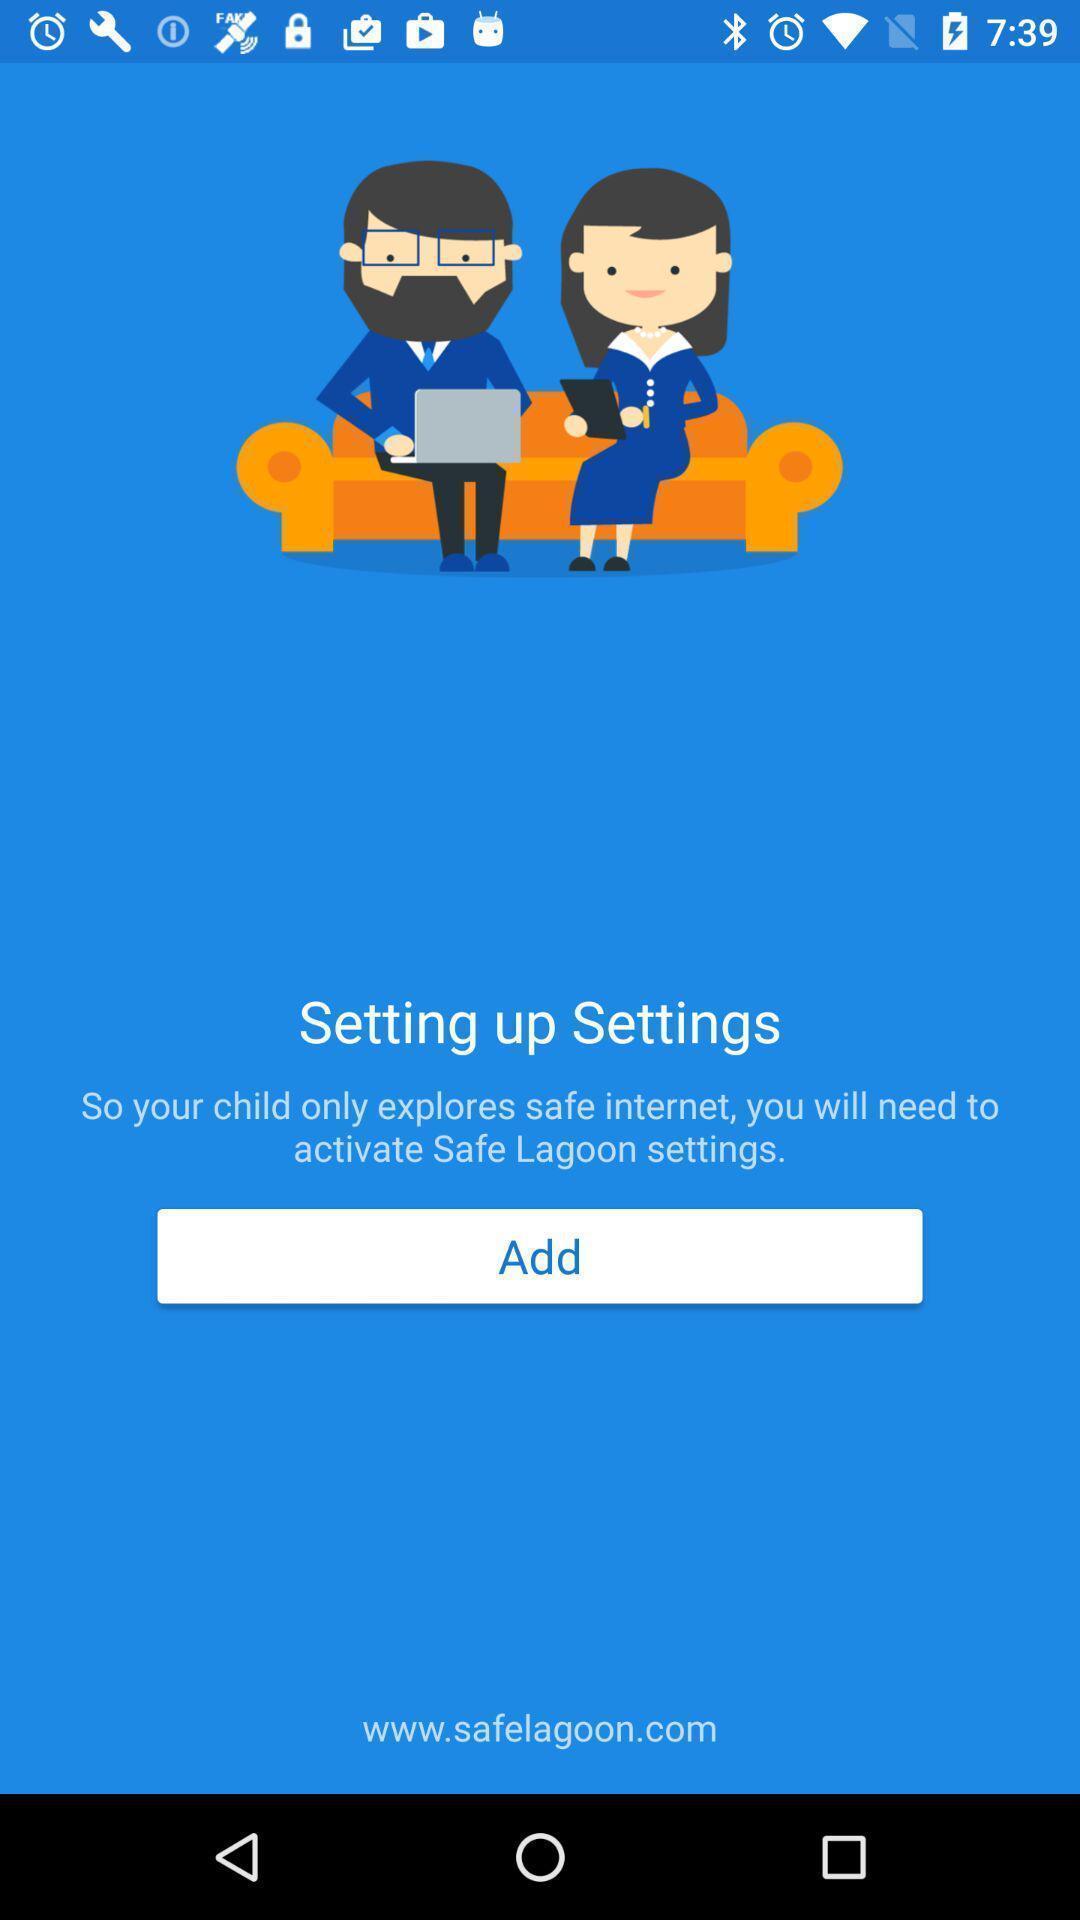Provide a detailed account of this screenshot. Page displaying settings information about online family protection application. 